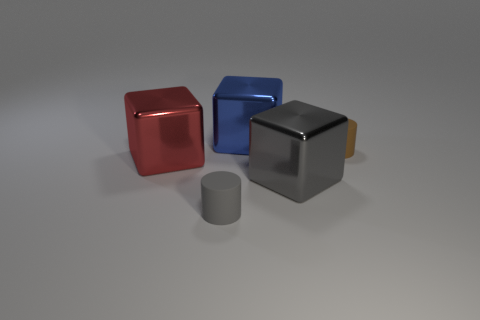Are there more tiny rubber objects that are to the left of the large red cube than blue things that are right of the big blue shiny cube?
Provide a succinct answer. No. What is the shape of the large thing that is in front of the block left of the cylinder that is on the left side of the gray block?
Provide a short and direct response. Cube. What shape is the big metal object to the left of the tiny rubber cylinder in front of the large gray block?
Your answer should be very brief. Cube. Is there a small brown cylinder made of the same material as the small gray thing?
Provide a short and direct response. Yes. What number of brown objects are small matte things or matte blocks?
Your response must be concise. 1. There is a gray block that is made of the same material as the large red object; what is its size?
Give a very brief answer. Large. What number of spheres are tiny gray objects or tiny blue matte things?
Make the answer very short. 0. Are there more large gray cubes than large objects?
Your answer should be very brief. No. What number of shiny cubes are the same size as the blue thing?
Ensure brevity in your answer.  2. What number of things are either shiny things to the left of the gray matte cylinder or blue objects?
Provide a succinct answer. 2. 